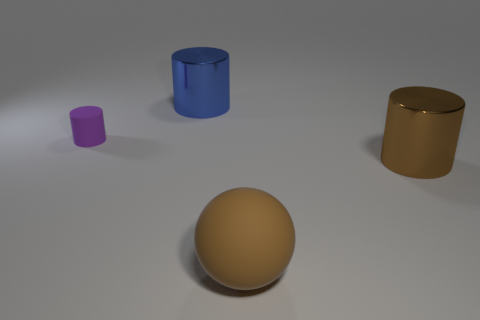How would you describe the arrangement of the objects? The objects are arranged with a clear space between them, each positioned separately on a flat surface. This arrangement allows each object to be distinctly visible and not overlapping in the visual field. 